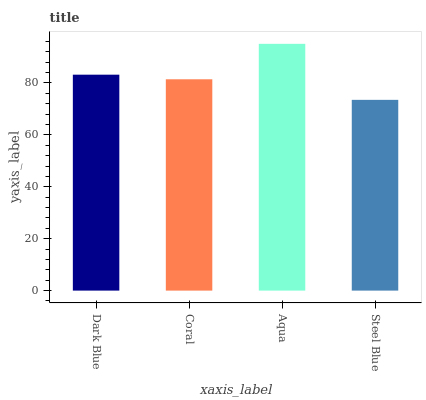Is Steel Blue the minimum?
Answer yes or no. Yes. Is Aqua the maximum?
Answer yes or no. Yes. Is Coral the minimum?
Answer yes or no. No. Is Coral the maximum?
Answer yes or no. No. Is Dark Blue greater than Coral?
Answer yes or no. Yes. Is Coral less than Dark Blue?
Answer yes or no. Yes. Is Coral greater than Dark Blue?
Answer yes or no. No. Is Dark Blue less than Coral?
Answer yes or no. No. Is Dark Blue the high median?
Answer yes or no. Yes. Is Coral the low median?
Answer yes or no. Yes. Is Aqua the high median?
Answer yes or no. No. Is Dark Blue the low median?
Answer yes or no. No. 